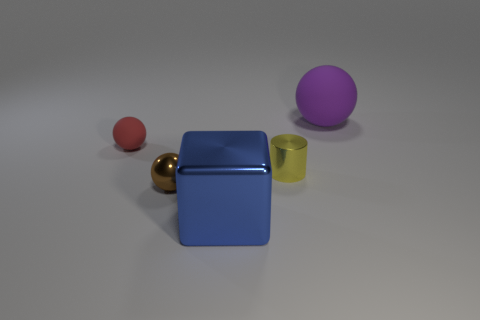Is the shape of the tiny red matte thing the same as the small brown thing?
Ensure brevity in your answer.  Yes. What number of red matte balls are right of the big metallic object on the left side of the rubber thing that is right of the tiny rubber thing?
Provide a succinct answer. 0. What is the shape of the brown thing that is made of the same material as the small yellow object?
Give a very brief answer. Sphere. What is the material of the large thing that is in front of the big object right of the tiny cylinder that is left of the big purple matte ball?
Provide a short and direct response. Metal. How many things are tiny shiny things behind the brown ball or large yellow metallic cylinders?
Your response must be concise. 1. What number of other things are there of the same shape as the brown metal object?
Your answer should be compact. 2. Are there more small metal spheres on the right side of the small matte sphere than green rubber cubes?
Make the answer very short. Yes. What size is the brown metallic thing that is the same shape as the red thing?
Keep it short and to the point. Small. What is the shape of the big purple rubber object?
Keep it short and to the point. Sphere. The blue shiny thing that is the same size as the purple matte sphere is what shape?
Ensure brevity in your answer.  Cube. 